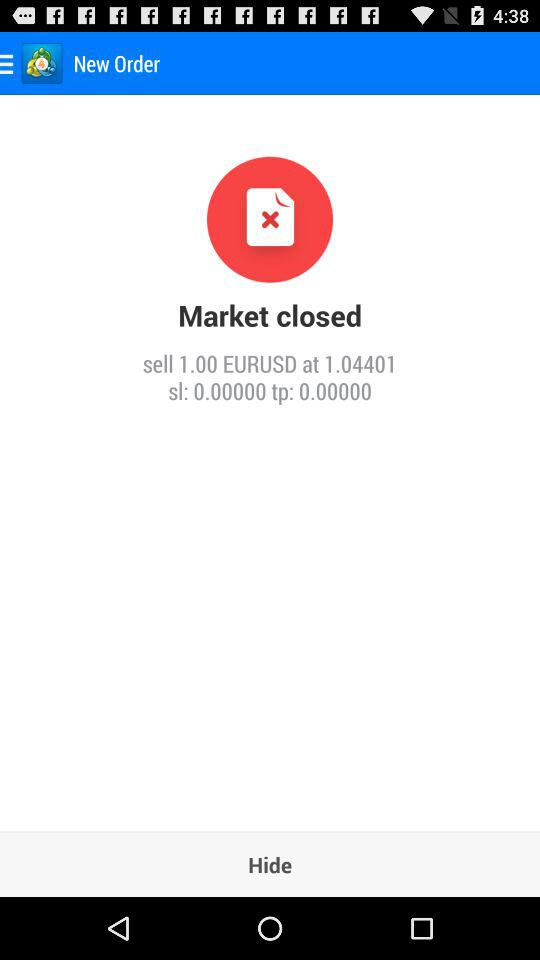At what price should I sell 1 EURUSD? You can sell 1 EURUSD at the price of 1.04401. 